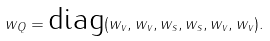Convert formula to latex. <formula><loc_0><loc_0><loc_500><loc_500>w _ { Q } = \text {diag} ( w _ { v } , w _ { v } , w _ { s } , w _ { s } , w _ { v } , w _ { v } ) .</formula> 